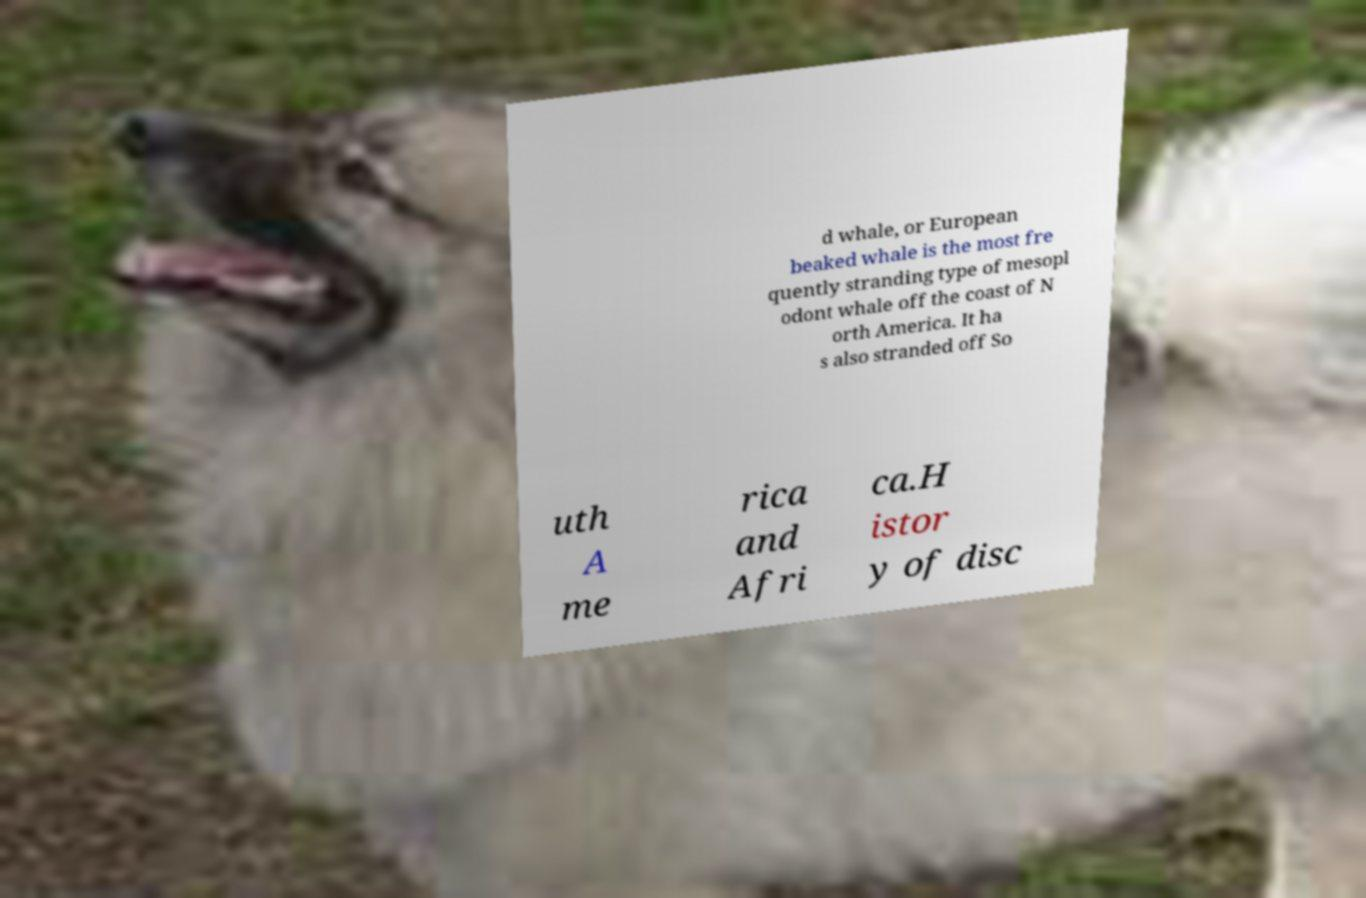Please identify and transcribe the text found in this image. d whale, or European beaked whale is the most fre quently stranding type of mesopl odont whale off the coast of N orth America. It ha s also stranded off So uth A me rica and Afri ca.H istor y of disc 